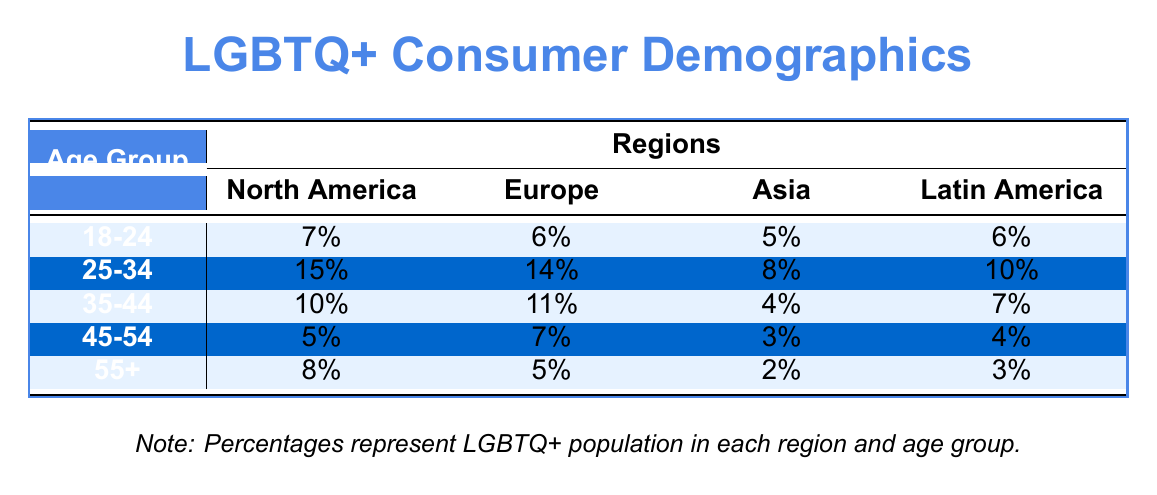What percentage of LGBTQ+ consumers in North America fall into the 25-34 age group? The table shows that the percentage of LGBTQ+ consumers aged 25-34 in North America is directly listed in the corresponding cell, which indicates 15%.
Answer: 15% Which age group has the highest percentage of LGBTQ+ consumers in Europe? By examining the Europe column, the 25-34 age group shows the highest percentage of 14%, which is greater than other age groups listed.
Answer: 25-34 What is the total percentage of LGBTQ+ consumers in the 45-54 age group across all regions? Adding the percentages from the 45-54 row yields: 5% (North America) + 7% (Europe) + 3% (Asia) + 4% (Latin America) = 19%.
Answer: 19% Is it true that the percentage of LGBTQ+ consumers aged 18-24 is higher in North America than in Asia? The table shows 7% for North America and 5% for Asia in the 18-24 age group. Thus, it is true that North America has a higher percentage.
Answer: Yes Which region has the lowest percentage of LGBTQ+ consumers in the 55+ age group? The percentages listed for the 55+ age group are 8% (North America), 5% (Europe), 2% (Asia), and 3% (Latin America). Asia records the lowest percentage at 2%.
Answer: Asia What is the average percentage of LGBTQ+ consumers for the 35-44 age group across all regions? The percentages for this age group are: 10% (North America), 11% (Europe), 4% (Asia), and 7% (Latin America). Summing them gives 10 + 11 + 4 + 7 = 32%. The average is then 32% / 4 = 8%.
Answer: 8% In which age group does Latin America have the highest percentage? The table shows that in Latin America the highest percentage among the age groups is in 25-34, which is 10%. This is higher compared to other age groups in the region.
Answer: 25-34 Are there more LGBTQ+ consumers aged 35-44 in Europe than in Latin America? The table indicates that Europe has 11% in the 35-44 age group while Latin America has 7%. Therefore, it is true that Europe has more consumers in this age group.
Answer: Yes Which region shows a consistent decline in percentage from the 18-24 to the 55+ age groups? Reviewing the percentages for each age group, the table indicates that Asia shows a decline: 5% (18-24), 8% (25-34), 4% (35-44), 3% (45-54), and 2% (55+), which shows a consistent downward trend.
Answer: Asia 